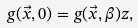Convert formula to latex. <formula><loc_0><loc_0><loc_500><loc_500>g ( \vec { x } , 0 ) = g ( \vec { x } , \beta ) z ,</formula> 